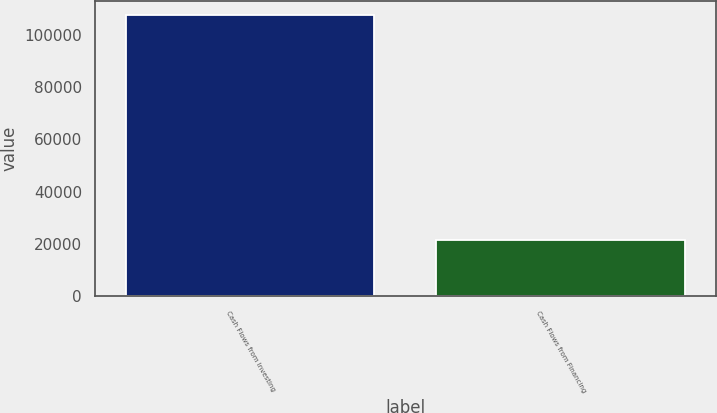<chart> <loc_0><loc_0><loc_500><loc_500><bar_chart><fcel>Cash Flows from Investing<fcel>Cash Flows from Financing<nl><fcel>107558<fcel>21489<nl></chart> 